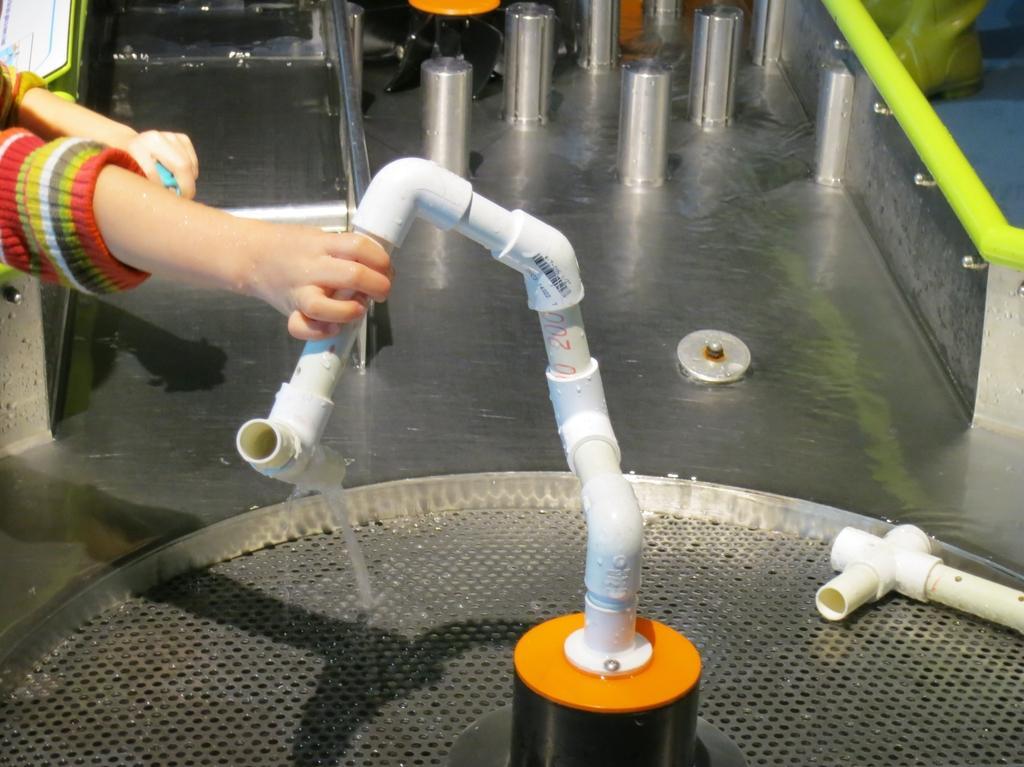How would you summarize this image in a sentence or two? As we can see in the image there is a person holding pipe and in the background there are steel rods and water. 